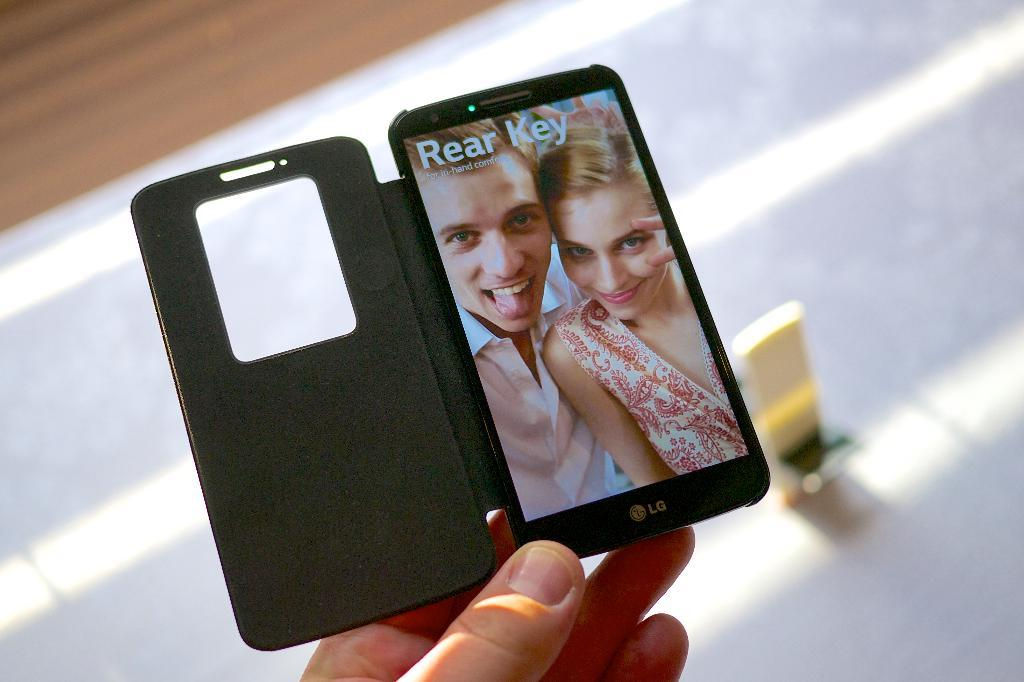<image>
Share a concise interpretation of the image provided. A person holding an LG phone displaying the Rear Key function. 